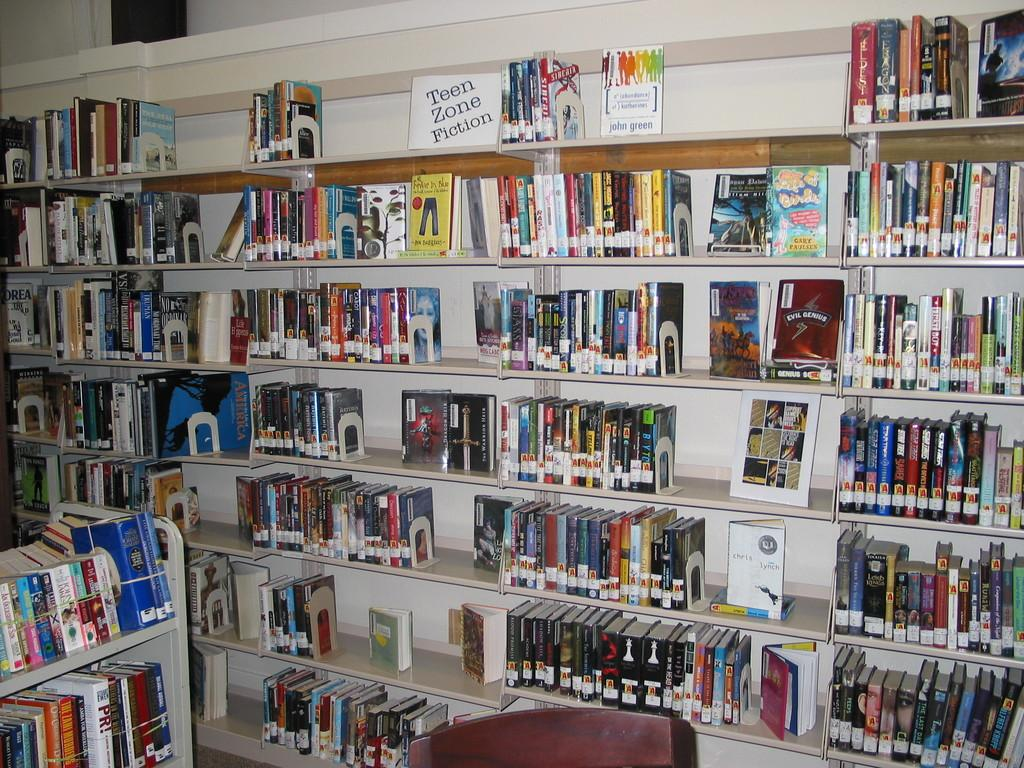What can be seen in the image? There are racks in the image. What are the racks filled with? The racks are filled with books. What is the shape of the discussion taking place in the image? There is no discussion present in the image; it only shows racks filled with books. 